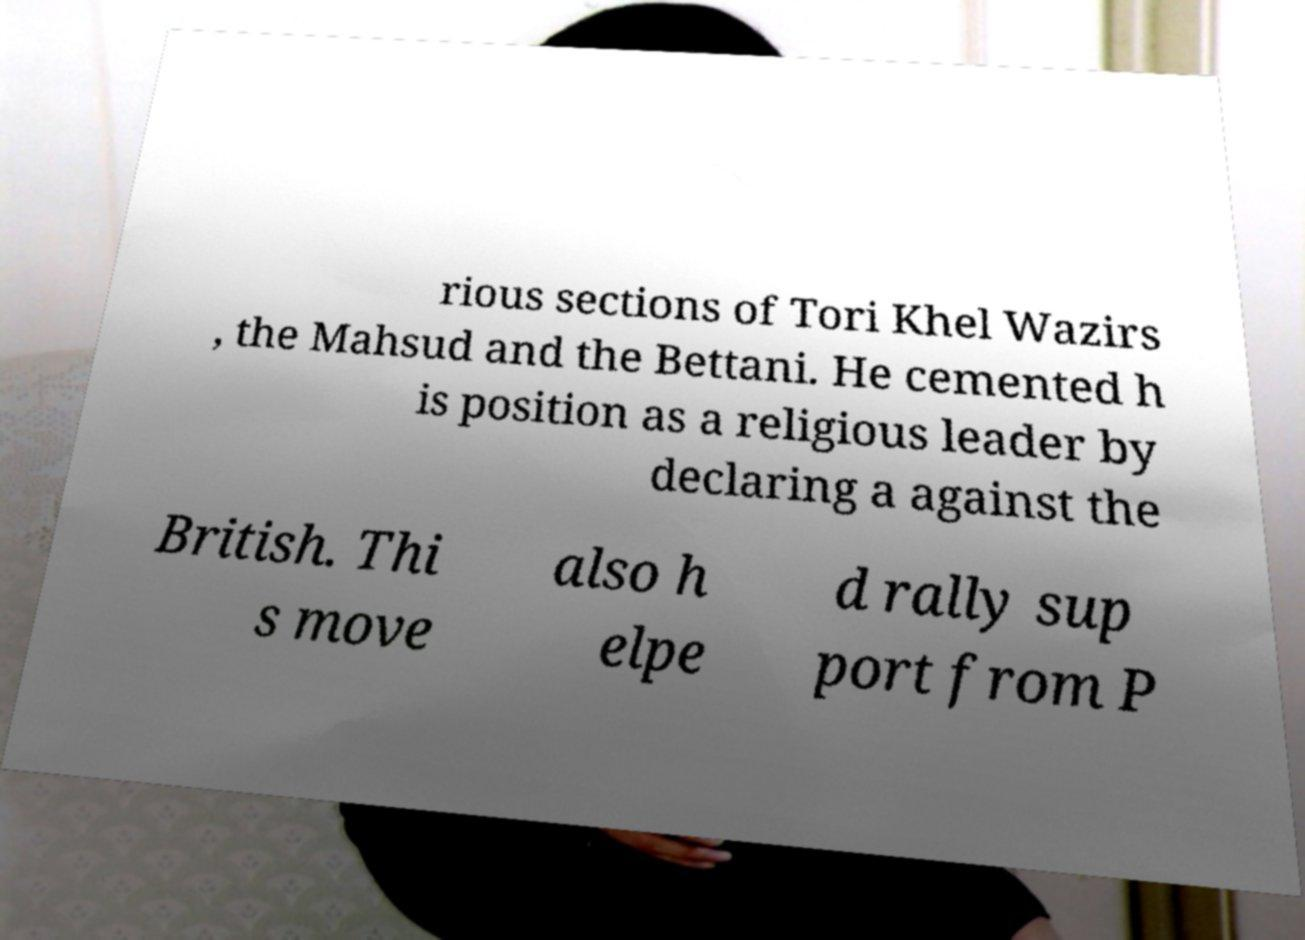There's text embedded in this image that I need extracted. Can you transcribe it verbatim? rious sections of Tori Khel Wazirs , the Mahsud and the Bettani. He cemented h is position as a religious leader by declaring a against the British. Thi s move also h elpe d rally sup port from P 